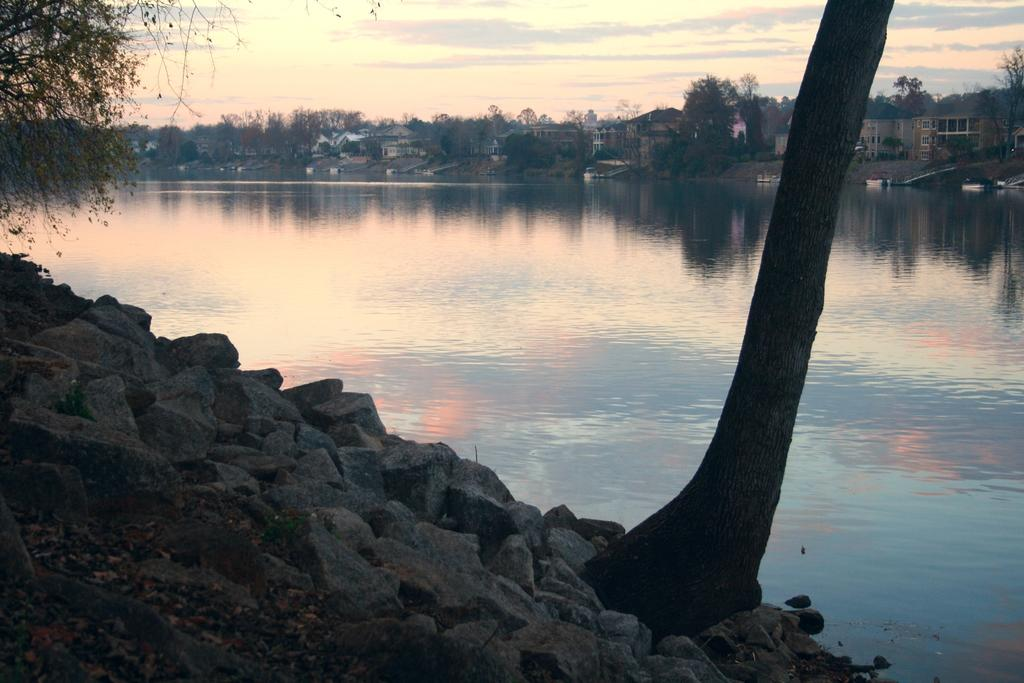What is present at the bottom of the image? There are rocks and grass at the bottom of the image. What can be seen in the background of the image? There is a lake, trees, and buildings in the background of the image. Is there any vegetation in the foreground of the image? Yes, there is a tree in the foreground of the image. What type of string is used to decorate the vase in the image? There is no vase present in the image, so there is no string to be considered. Is there a crown visible on the tree in the foreground of the image? There is no crown present on the tree in the foreground of the image. 